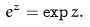Convert formula to latex. <formula><loc_0><loc_0><loc_500><loc_500>e ^ { z } = \exp z .</formula> 